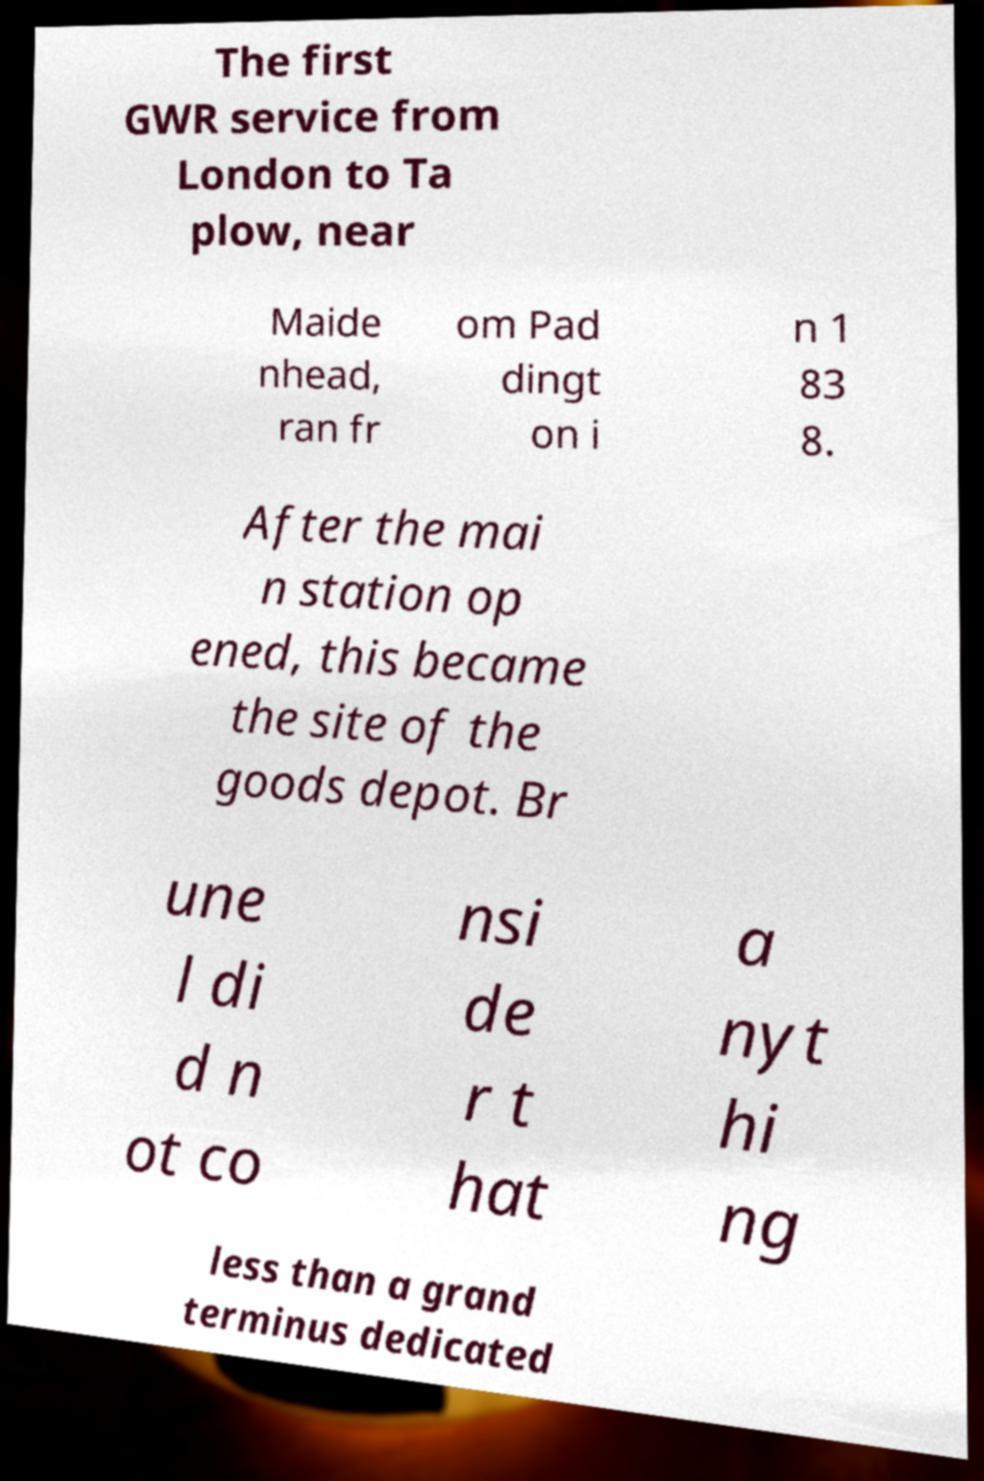Please read and relay the text visible in this image. What does it say? The first GWR service from London to Ta plow, near Maide nhead, ran fr om Pad dingt on i n 1 83 8. After the mai n station op ened, this became the site of the goods depot. Br une l di d n ot co nsi de r t hat a nyt hi ng less than a grand terminus dedicated 